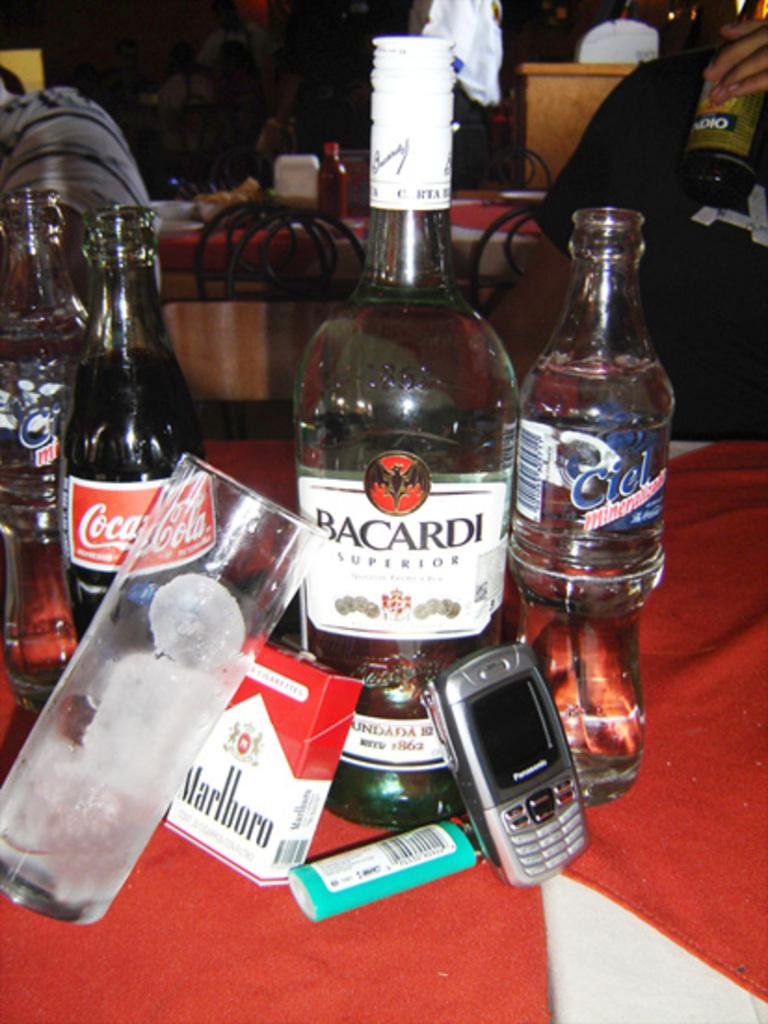<image>
Present a compact description of the photo's key features. A group of bottles including Bacardi Superior are next to a cellphone, a lighter, and a pack of Marlboro's. 